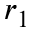<formula> <loc_0><loc_0><loc_500><loc_500>r _ { 1 }</formula> 